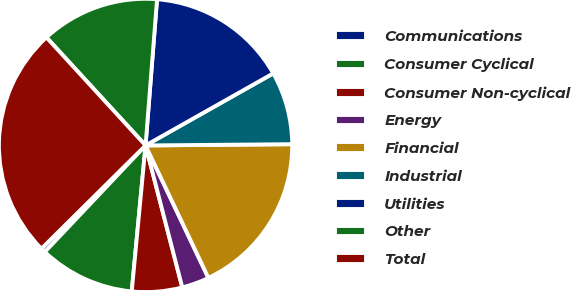Convert chart to OTSL. <chart><loc_0><loc_0><loc_500><loc_500><pie_chart><fcel>Communications<fcel>Consumer Cyclical<fcel>Consumer Non-cyclical<fcel>Energy<fcel>Financial<fcel>Industrial<fcel>Utilities<fcel>Other<fcel>Total<nl><fcel>0.51%<fcel>10.55%<fcel>5.53%<fcel>3.02%<fcel>18.08%<fcel>8.04%<fcel>15.57%<fcel>13.06%<fcel>25.61%<nl></chart> 